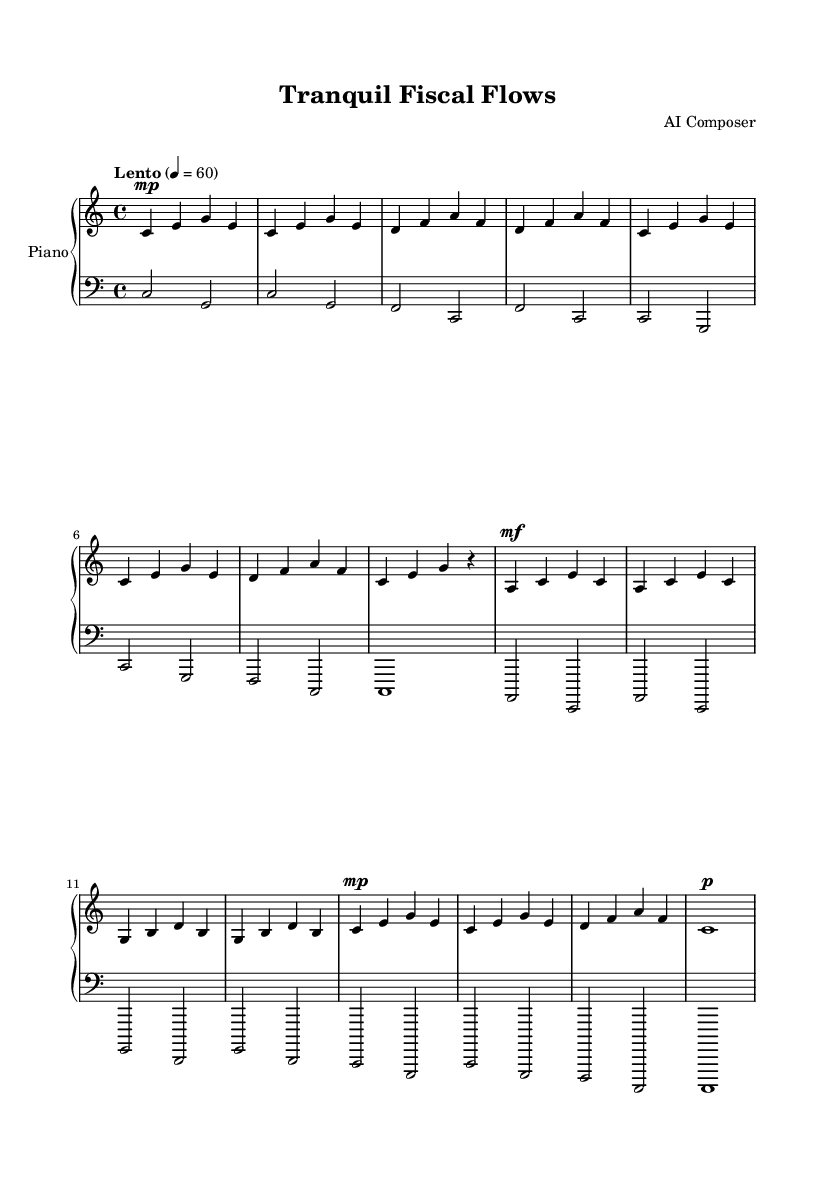What is the key signature of this music? The key signature is indicated at the beginning of the staff, showing no sharps or flats. Therefore, it is in C major.
Answer: C major What is the time signature of this music? The time signature is indicated at the beginning of the score, which shows a 4/4 time signature, meaning there are four beats in a measure.
Answer: 4/4 What is the tempo marking for this piece? The tempo marking appears above the staff, stating "Lento" which indicates a slow tempo, and specifies a metronome marking of 60 beats per minute.
Answer: Lento, 60 How many measures does the music have? By counting the measures outlined by the vertical bar lines, there are a total of twelve measures present in this composition.
Answer: 12 In which clef is the left hand written? The left hand is notated in the bass clef as indicated by the clef symbol at the beginning of the left hand staff.
Answer: Bass What dynamic marking is indicated for the first section of the right hand? The first section of the right hand has a dynamic marking of "mp," which means mezzo-piano or moderately soft.
Answer: mp Is there a conclusion or final note indicated in this piece? The final measure of the right hand indicates a whole note tied to a rest, which serves to conclude the piece. The left hand also completes with a whole note.
Answer: c1 